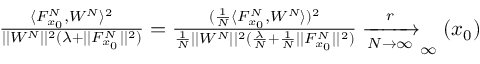<formula> <loc_0><loc_0><loc_500><loc_500>\begin{array} { r } { \frac { \langle F _ { x _ { 0 } } ^ { N } , W ^ { N } \rangle ^ { 2 } } { | | W ^ { N } | | ^ { 2 } ( \lambda + | | F _ { x _ { 0 } } ^ { N } | | ^ { 2 } ) } = \frac { ( \frac { 1 } { N } \langle F _ { x _ { 0 } } ^ { N } , W ^ { N } \rangle ) ^ { 2 } } { \frac { 1 } { N } | | W ^ { N } | | ^ { 2 } ( \frac { \lambda } { N } + \frac { 1 } { N } | | F _ { x _ { 0 } } ^ { N } | | ^ { 2 } ) } \xrightarrow [ N \rightarrow \infty ] r _ { \infty } ( x _ { 0 } ) } \end{array}</formula> 